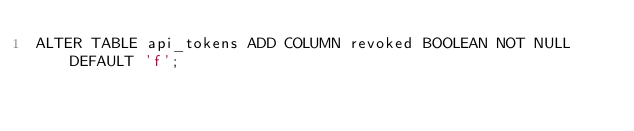<code> <loc_0><loc_0><loc_500><loc_500><_SQL_>ALTER TABLE api_tokens ADD COLUMN revoked BOOLEAN NOT NULL DEFAULT 'f';
</code> 